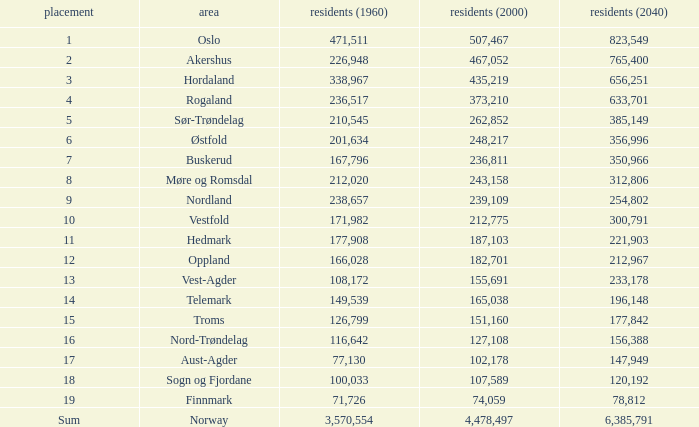What was the population of a county in 2040 that had a population less than 108,172 in 2000 and less than 107,589 in 1960? 2.0. 